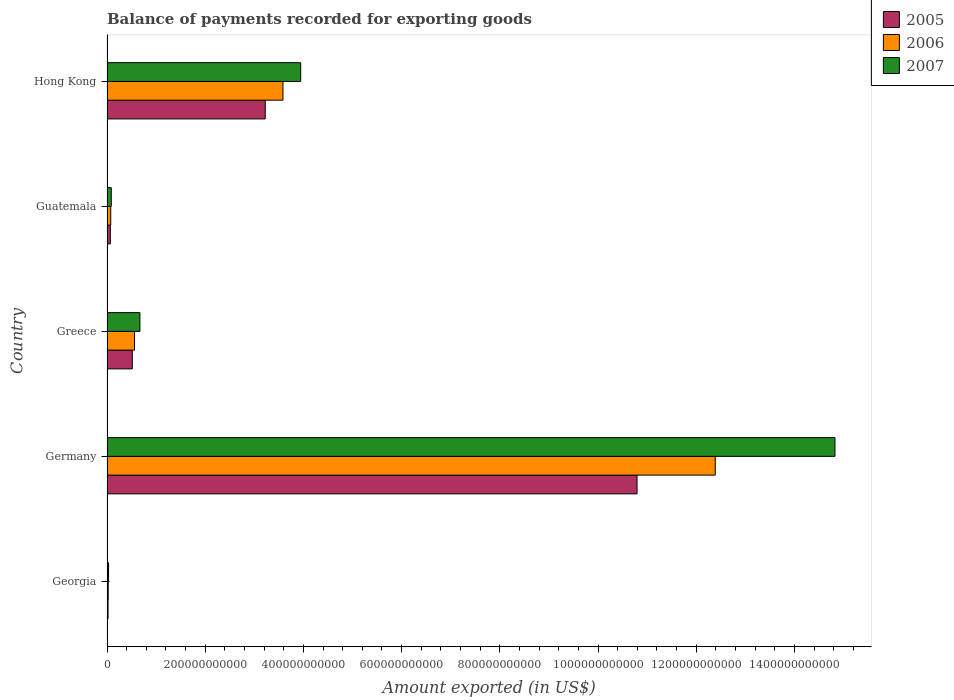Are the number of bars per tick equal to the number of legend labels?
Offer a terse response. Yes. Are the number of bars on each tick of the Y-axis equal?
Offer a terse response. Yes. How many bars are there on the 2nd tick from the top?
Your response must be concise. 3. What is the label of the 1st group of bars from the top?
Provide a succinct answer. Hong Kong. In how many cases, is the number of bars for a given country not equal to the number of legend labels?
Provide a short and direct response. 0. What is the amount exported in 2005 in Germany?
Keep it short and to the point. 1.08e+12. Across all countries, what is the maximum amount exported in 2006?
Offer a very short reply. 1.24e+12. Across all countries, what is the minimum amount exported in 2006?
Offer a terse response. 2.50e+09. In which country was the amount exported in 2006 maximum?
Keep it short and to the point. Germany. In which country was the amount exported in 2007 minimum?
Give a very brief answer. Georgia. What is the total amount exported in 2006 in the graph?
Your answer should be very brief. 1.66e+12. What is the difference between the amount exported in 2007 in Guatemala and that in Hong Kong?
Your answer should be compact. -3.86e+11. What is the difference between the amount exported in 2006 in Guatemala and the amount exported in 2007 in Hong Kong?
Offer a very short reply. -3.87e+11. What is the average amount exported in 2006 per country?
Keep it short and to the point. 3.33e+11. What is the difference between the amount exported in 2006 and amount exported in 2007 in Germany?
Provide a succinct answer. -2.44e+11. In how many countries, is the amount exported in 2005 greater than 720000000000 US$?
Your response must be concise. 1. What is the ratio of the amount exported in 2005 in Greece to that in Hong Kong?
Ensure brevity in your answer.  0.16. What is the difference between the highest and the second highest amount exported in 2007?
Your response must be concise. 1.09e+12. What is the difference between the highest and the lowest amount exported in 2005?
Your response must be concise. 1.08e+12. In how many countries, is the amount exported in 2006 greater than the average amount exported in 2006 taken over all countries?
Your response must be concise. 2. Is it the case that in every country, the sum of the amount exported in 2006 and amount exported in 2007 is greater than the amount exported in 2005?
Your answer should be very brief. Yes. How many countries are there in the graph?
Ensure brevity in your answer.  5. What is the difference between two consecutive major ticks on the X-axis?
Your answer should be very brief. 2.00e+11. Are the values on the major ticks of X-axis written in scientific E-notation?
Offer a very short reply. No. Where does the legend appear in the graph?
Your answer should be compact. Top right. What is the title of the graph?
Your answer should be compact. Balance of payments recorded for exporting goods. What is the label or title of the X-axis?
Offer a very short reply. Amount exported (in US$). What is the label or title of the Y-axis?
Provide a succinct answer. Country. What is the Amount exported (in US$) in 2005 in Georgia?
Your response must be concise. 2.15e+09. What is the Amount exported (in US$) in 2006 in Georgia?
Provide a succinct answer. 2.50e+09. What is the Amount exported (in US$) of 2007 in Georgia?
Give a very brief answer. 3.16e+09. What is the Amount exported (in US$) in 2005 in Germany?
Give a very brief answer. 1.08e+12. What is the Amount exported (in US$) in 2006 in Germany?
Your response must be concise. 1.24e+12. What is the Amount exported (in US$) in 2007 in Germany?
Offer a very short reply. 1.48e+12. What is the Amount exported (in US$) of 2005 in Greece?
Give a very brief answer. 5.15e+1. What is the Amount exported (in US$) of 2006 in Greece?
Your answer should be very brief. 5.60e+1. What is the Amount exported (in US$) of 2007 in Greece?
Give a very brief answer. 6.70e+1. What is the Amount exported (in US$) of 2005 in Guatemala?
Offer a terse response. 6.77e+09. What is the Amount exported (in US$) in 2006 in Guatemala?
Offer a terse response. 7.60e+09. What is the Amount exported (in US$) in 2007 in Guatemala?
Provide a short and direct response. 8.71e+09. What is the Amount exported (in US$) in 2005 in Hong Kong?
Provide a short and direct response. 3.22e+11. What is the Amount exported (in US$) in 2006 in Hong Kong?
Provide a short and direct response. 3.58e+11. What is the Amount exported (in US$) of 2007 in Hong Kong?
Provide a succinct answer. 3.94e+11. Across all countries, what is the maximum Amount exported (in US$) of 2005?
Give a very brief answer. 1.08e+12. Across all countries, what is the maximum Amount exported (in US$) in 2006?
Your answer should be compact. 1.24e+12. Across all countries, what is the maximum Amount exported (in US$) in 2007?
Provide a short and direct response. 1.48e+12. Across all countries, what is the minimum Amount exported (in US$) of 2005?
Offer a very short reply. 2.15e+09. Across all countries, what is the minimum Amount exported (in US$) of 2006?
Your answer should be very brief. 2.50e+09. Across all countries, what is the minimum Amount exported (in US$) in 2007?
Provide a short and direct response. 3.16e+09. What is the total Amount exported (in US$) in 2005 in the graph?
Make the answer very short. 1.46e+12. What is the total Amount exported (in US$) in 2006 in the graph?
Keep it short and to the point. 1.66e+12. What is the total Amount exported (in US$) in 2007 in the graph?
Your response must be concise. 1.96e+12. What is the difference between the Amount exported (in US$) in 2005 in Georgia and that in Germany?
Offer a very short reply. -1.08e+12. What is the difference between the Amount exported (in US$) in 2006 in Georgia and that in Germany?
Your answer should be compact. -1.24e+12. What is the difference between the Amount exported (in US$) of 2007 in Georgia and that in Germany?
Provide a short and direct response. -1.48e+12. What is the difference between the Amount exported (in US$) in 2005 in Georgia and that in Greece?
Provide a succinct answer. -4.94e+1. What is the difference between the Amount exported (in US$) of 2006 in Georgia and that in Greece?
Your answer should be compact. -5.35e+1. What is the difference between the Amount exported (in US$) in 2007 in Georgia and that in Greece?
Your answer should be compact. -6.39e+1. What is the difference between the Amount exported (in US$) of 2005 in Georgia and that in Guatemala?
Your answer should be very brief. -4.62e+09. What is the difference between the Amount exported (in US$) of 2006 in Georgia and that in Guatemala?
Make the answer very short. -5.10e+09. What is the difference between the Amount exported (in US$) of 2007 in Georgia and that in Guatemala?
Ensure brevity in your answer.  -5.55e+09. What is the difference between the Amount exported (in US$) in 2005 in Georgia and that in Hong Kong?
Your answer should be very brief. -3.20e+11. What is the difference between the Amount exported (in US$) of 2006 in Georgia and that in Hong Kong?
Keep it short and to the point. -3.56e+11. What is the difference between the Amount exported (in US$) in 2007 in Georgia and that in Hong Kong?
Ensure brevity in your answer.  -3.91e+11. What is the difference between the Amount exported (in US$) of 2005 in Germany and that in Greece?
Offer a very short reply. 1.03e+12. What is the difference between the Amount exported (in US$) of 2006 in Germany and that in Greece?
Keep it short and to the point. 1.18e+12. What is the difference between the Amount exported (in US$) of 2007 in Germany and that in Greece?
Provide a short and direct response. 1.42e+12. What is the difference between the Amount exported (in US$) in 2005 in Germany and that in Guatemala?
Your response must be concise. 1.07e+12. What is the difference between the Amount exported (in US$) of 2006 in Germany and that in Guatemala?
Provide a succinct answer. 1.23e+12. What is the difference between the Amount exported (in US$) of 2007 in Germany and that in Guatemala?
Keep it short and to the point. 1.47e+12. What is the difference between the Amount exported (in US$) of 2005 in Germany and that in Hong Kong?
Provide a succinct answer. 7.57e+11. What is the difference between the Amount exported (in US$) of 2006 in Germany and that in Hong Kong?
Give a very brief answer. 8.80e+11. What is the difference between the Amount exported (in US$) of 2007 in Germany and that in Hong Kong?
Provide a short and direct response. 1.09e+12. What is the difference between the Amount exported (in US$) of 2005 in Greece and that in Guatemala?
Provide a short and direct response. 4.48e+1. What is the difference between the Amount exported (in US$) in 2006 in Greece and that in Guatemala?
Give a very brief answer. 4.84e+1. What is the difference between the Amount exported (in US$) of 2007 in Greece and that in Guatemala?
Your answer should be very brief. 5.83e+1. What is the difference between the Amount exported (in US$) of 2005 in Greece and that in Hong Kong?
Offer a terse response. -2.71e+11. What is the difference between the Amount exported (in US$) in 2006 in Greece and that in Hong Kong?
Keep it short and to the point. -3.02e+11. What is the difference between the Amount exported (in US$) in 2007 in Greece and that in Hong Kong?
Offer a very short reply. -3.27e+11. What is the difference between the Amount exported (in US$) of 2005 in Guatemala and that in Hong Kong?
Give a very brief answer. -3.15e+11. What is the difference between the Amount exported (in US$) in 2006 in Guatemala and that in Hong Kong?
Your answer should be compact. -3.51e+11. What is the difference between the Amount exported (in US$) of 2007 in Guatemala and that in Hong Kong?
Ensure brevity in your answer.  -3.86e+11. What is the difference between the Amount exported (in US$) in 2005 in Georgia and the Amount exported (in US$) in 2006 in Germany?
Your answer should be compact. -1.24e+12. What is the difference between the Amount exported (in US$) in 2005 in Georgia and the Amount exported (in US$) in 2007 in Germany?
Offer a very short reply. -1.48e+12. What is the difference between the Amount exported (in US$) of 2006 in Georgia and the Amount exported (in US$) of 2007 in Germany?
Your answer should be very brief. -1.48e+12. What is the difference between the Amount exported (in US$) in 2005 in Georgia and the Amount exported (in US$) in 2006 in Greece?
Your response must be concise. -5.39e+1. What is the difference between the Amount exported (in US$) of 2005 in Georgia and the Amount exported (in US$) of 2007 in Greece?
Offer a terse response. -6.49e+1. What is the difference between the Amount exported (in US$) of 2006 in Georgia and the Amount exported (in US$) of 2007 in Greece?
Your response must be concise. -6.45e+1. What is the difference between the Amount exported (in US$) of 2005 in Georgia and the Amount exported (in US$) of 2006 in Guatemala?
Provide a short and direct response. -5.45e+09. What is the difference between the Amount exported (in US$) of 2005 in Georgia and the Amount exported (in US$) of 2007 in Guatemala?
Keep it short and to the point. -6.56e+09. What is the difference between the Amount exported (in US$) of 2006 in Georgia and the Amount exported (in US$) of 2007 in Guatemala?
Your answer should be very brief. -6.21e+09. What is the difference between the Amount exported (in US$) of 2005 in Georgia and the Amount exported (in US$) of 2006 in Hong Kong?
Give a very brief answer. -3.56e+11. What is the difference between the Amount exported (in US$) in 2005 in Georgia and the Amount exported (in US$) in 2007 in Hong Kong?
Ensure brevity in your answer.  -3.92e+11. What is the difference between the Amount exported (in US$) of 2006 in Georgia and the Amount exported (in US$) of 2007 in Hong Kong?
Your answer should be very brief. -3.92e+11. What is the difference between the Amount exported (in US$) in 2005 in Germany and the Amount exported (in US$) in 2006 in Greece?
Make the answer very short. 1.02e+12. What is the difference between the Amount exported (in US$) of 2005 in Germany and the Amount exported (in US$) of 2007 in Greece?
Make the answer very short. 1.01e+12. What is the difference between the Amount exported (in US$) in 2006 in Germany and the Amount exported (in US$) in 2007 in Greece?
Give a very brief answer. 1.17e+12. What is the difference between the Amount exported (in US$) in 2005 in Germany and the Amount exported (in US$) in 2006 in Guatemala?
Your answer should be compact. 1.07e+12. What is the difference between the Amount exported (in US$) of 2005 in Germany and the Amount exported (in US$) of 2007 in Guatemala?
Your response must be concise. 1.07e+12. What is the difference between the Amount exported (in US$) of 2006 in Germany and the Amount exported (in US$) of 2007 in Guatemala?
Offer a terse response. 1.23e+12. What is the difference between the Amount exported (in US$) of 2005 in Germany and the Amount exported (in US$) of 2006 in Hong Kong?
Provide a short and direct response. 7.21e+11. What is the difference between the Amount exported (in US$) of 2005 in Germany and the Amount exported (in US$) of 2007 in Hong Kong?
Provide a short and direct response. 6.85e+11. What is the difference between the Amount exported (in US$) in 2006 in Germany and the Amount exported (in US$) in 2007 in Hong Kong?
Your response must be concise. 8.44e+11. What is the difference between the Amount exported (in US$) in 2005 in Greece and the Amount exported (in US$) in 2006 in Guatemala?
Ensure brevity in your answer.  4.39e+1. What is the difference between the Amount exported (in US$) in 2005 in Greece and the Amount exported (in US$) in 2007 in Guatemala?
Offer a very short reply. 4.28e+1. What is the difference between the Amount exported (in US$) in 2006 in Greece and the Amount exported (in US$) in 2007 in Guatemala?
Offer a very short reply. 4.73e+1. What is the difference between the Amount exported (in US$) of 2005 in Greece and the Amount exported (in US$) of 2006 in Hong Kong?
Your response must be concise. -3.07e+11. What is the difference between the Amount exported (in US$) in 2005 in Greece and the Amount exported (in US$) in 2007 in Hong Kong?
Keep it short and to the point. -3.43e+11. What is the difference between the Amount exported (in US$) of 2006 in Greece and the Amount exported (in US$) of 2007 in Hong Kong?
Your answer should be compact. -3.38e+11. What is the difference between the Amount exported (in US$) in 2005 in Guatemala and the Amount exported (in US$) in 2006 in Hong Kong?
Ensure brevity in your answer.  -3.52e+11. What is the difference between the Amount exported (in US$) of 2005 in Guatemala and the Amount exported (in US$) of 2007 in Hong Kong?
Your answer should be compact. -3.88e+11. What is the difference between the Amount exported (in US$) in 2006 in Guatemala and the Amount exported (in US$) in 2007 in Hong Kong?
Make the answer very short. -3.87e+11. What is the average Amount exported (in US$) of 2005 per country?
Offer a very short reply. 2.92e+11. What is the average Amount exported (in US$) in 2006 per country?
Ensure brevity in your answer.  3.33e+11. What is the average Amount exported (in US$) in 2007 per country?
Your answer should be compact. 3.91e+11. What is the difference between the Amount exported (in US$) in 2005 and Amount exported (in US$) in 2006 in Georgia?
Your answer should be very brief. -3.48e+08. What is the difference between the Amount exported (in US$) in 2005 and Amount exported (in US$) in 2007 in Georgia?
Provide a succinct answer. -1.01e+09. What is the difference between the Amount exported (in US$) in 2006 and Amount exported (in US$) in 2007 in Georgia?
Make the answer very short. -6.63e+08. What is the difference between the Amount exported (in US$) of 2005 and Amount exported (in US$) of 2006 in Germany?
Provide a short and direct response. -1.59e+11. What is the difference between the Amount exported (in US$) of 2005 and Amount exported (in US$) of 2007 in Germany?
Offer a terse response. -4.03e+11. What is the difference between the Amount exported (in US$) in 2006 and Amount exported (in US$) in 2007 in Germany?
Make the answer very short. -2.44e+11. What is the difference between the Amount exported (in US$) of 2005 and Amount exported (in US$) of 2006 in Greece?
Offer a terse response. -4.51e+09. What is the difference between the Amount exported (in US$) in 2005 and Amount exported (in US$) in 2007 in Greece?
Your answer should be compact. -1.55e+1. What is the difference between the Amount exported (in US$) of 2006 and Amount exported (in US$) of 2007 in Greece?
Provide a succinct answer. -1.10e+1. What is the difference between the Amount exported (in US$) of 2005 and Amount exported (in US$) of 2006 in Guatemala?
Your response must be concise. -8.34e+08. What is the difference between the Amount exported (in US$) of 2005 and Amount exported (in US$) of 2007 in Guatemala?
Give a very brief answer. -1.95e+09. What is the difference between the Amount exported (in US$) of 2006 and Amount exported (in US$) of 2007 in Guatemala?
Your answer should be very brief. -1.11e+09. What is the difference between the Amount exported (in US$) in 2005 and Amount exported (in US$) in 2006 in Hong Kong?
Provide a succinct answer. -3.61e+1. What is the difference between the Amount exported (in US$) in 2005 and Amount exported (in US$) in 2007 in Hong Kong?
Your answer should be compact. -7.22e+1. What is the difference between the Amount exported (in US$) in 2006 and Amount exported (in US$) in 2007 in Hong Kong?
Your response must be concise. -3.61e+1. What is the ratio of the Amount exported (in US$) in 2005 in Georgia to that in Germany?
Ensure brevity in your answer.  0. What is the ratio of the Amount exported (in US$) of 2006 in Georgia to that in Germany?
Ensure brevity in your answer.  0. What is the ratio of the Amount exported (in US$) of 2007 in Georgia to that in Germany?
Offer a very short reply. 0. What is the ratio of the Amount exported (in US$) of 2005 in Georgia to that in Greece?
Offer a terse response. 0.04. What is the ratio of the Amount exported (in US$) of 2006 in Georgia to that in Greece?
Make the answer very short. 0.04. What is the ratio of the Amount exported (in US$) in 2007 in Georgia to that in Greece?
Provide a succinct answer. 0.05. What is the ratio of the Amount exported (in US$) in 2005 in Georgia to that in Guatemala?
Offer a terse response. 0.32. What is the ratio of the Amount exported (in US$) in 2006 in Georgia to that in Guatemala?
Ensure brevity in your answer.  0.33. What is the ratio of the Amount exported (in US$) in 2007 in Georgia to that in Guatemala?
Keep it short and to the point. 0.36. What is the ratio of the Amount exported (in US$) of 2005 in Georgia to that in Hong Kong?
Provide a succinct answer. 0.01. What is the ratio of the Amount exported (in US$) in 2006 in Georgia to that in Hong Kong?
Provide a succinct answer. 0.01. What is the ratio of the Amount exported (in US$) in 2007 in Georgia to that in Hong Kong?
Provide a short and direct response. 0.01. What is the ratio of the Amount exported (in US$) of 2005 in Germany to that in Greece?
Give a very brief answer. 20.95. What is the ratio of the Amount exported (in US$) of 2006 in Germany to that in Greece?
Offer a terse response. 22.11. What is the ratio of the Amount exported (in US$) in 2007 in Germany to that in Greece?
Offer a very short reply. 22.11. What is the ratio of the Amount exported (in US$) in 2005 in Germany to that in Guatemala?
Provide a succinct answer. 159.51. What is the ratio of the Amount exported (in US$) in 2006 in Germany to that in Guatemala?
Your answer should be compact. 162.97. What is the ratio of the Amount exported (in US$) in 2007 in Germany to that in Guatemala?
Offer a very short reply. 170.12. What is the ratio of the Amount exported (in US$) in 2005 in Germany to that in Hong Kong?
Provide a succinct answer. 3.35. What is the ratio of the Amount exported (in US$) in 2006 in Germany to that in Hong Kong?
Offer a terse response. 3.46. What is the ratio of the Amount exported (in US$) of 2007 in Germany to that in Hong Kong?
Provide a succinct answer. 3.76. What is the ratio of the Amount exported (in US$) in 2005 in Greece to that in Guatemala?
Your response must be concise. 7.61. What is the ratio of the Amount exported (in US$) in 2006 in Greece to that in Guatemala?
Your response must be concise. 7.37. What is the ratio of the Amount exported (in US$) of 2007 in Greece to that in Guatemala?
Provide a short and direct response. 7.69. What is the ratio of the Amount exported (in US$) of 2005 in Greece to that in Hong Kong?
Keep it short and to the point. 0.16. What is the ratio of the Amount exported (in US$) in 2006 in Greece to that in Hong Kong?
Offer a very short reply. 0.16. What is the ratio of the Amount exported (in US$) of 2007 in Greece to that in Hong Kong?
Offer a terse response. 0.17. What is the ratio of the Amount exported (in US$) in 2005 in Guatemala to that in Hong Kong?
Your answer should be very brief. 0.02. What is the ratio of the Amount exported (in US$) of 2006 in Guatemala to that in Hong Kong?
Your answer should be very brief. 0.02. What is the ratio of the Amount exported (in US$) of 2007 in Guatemala to that in Hong Kong?
Keep it short and to the point. 0.02. What is the difference between the highest and the second highest Amount exported (in US$) in 2005?
Provide a short and direct response. 7.57e+11. What is the difference between the highest and the second highest Amount exported (in US$) of 2006?
Offer a terse response. 8.80e+11. What is the difference between the highest and the second highest Amount exported (in US$) in 2007?
Your answer should be compact. 1.09e+12. What is the difference between the highest and the lowest Amount exported (in US$) in 2005?
Keep it short and to the point. 1.08e+12. What is the difference between the highest and the lowest Amount exported (in US$) in 2006?
Your answer should be compact. 1.24e+12. What is the difference between the highest and the lowest Amount exported (in US$) in 2007?
Offer a terse response. 1.48e+12. 